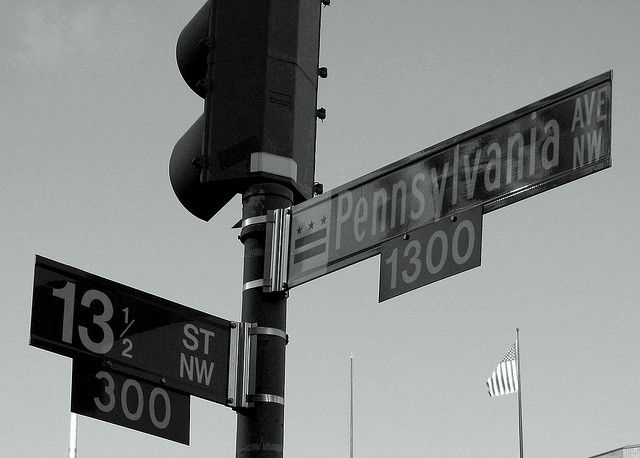<image>Why does this black and white photo of a street sign say thirteen an half st? It is unknown why the black and white photo of a street sign says thirteen and a half st. It may be the street's name. Why does this black and white photo of a street sign say thirteen an half st? I don't know why this black and white photo of a street sign says thirteen and a half st. 